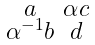Convert formula to latex. <formula><loc_0><loc_0><loc_500><loc_500>\begin{smallmatrix} a & \alpha c \\ \alpha ^ { - 1 } b & d \end{smallmatrix}</formula> 